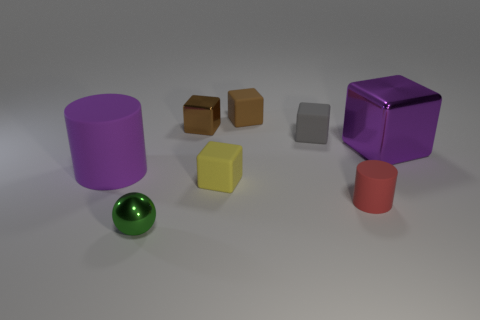Subtract all purple blocks. How many blocks are left? 4 Subtract all large purple metal blocks. How many blocks are left? 4 Subtract all purple blocks. Subtract all gray spheres. How many blocks are left? 4 Add 1 small yellow rubber things. How many objects exist? 9 Subtract all balls. How many objects are left? 7 Add 7 balls. How many balls are left? 8 Add 4 brown objects. How many brown objects exist? 6 Subtract 1 gray cubes. How many objects are left? 7 Subtract all green rubber blocks. Subtract all green shiny objects. How many objects are left? 7 